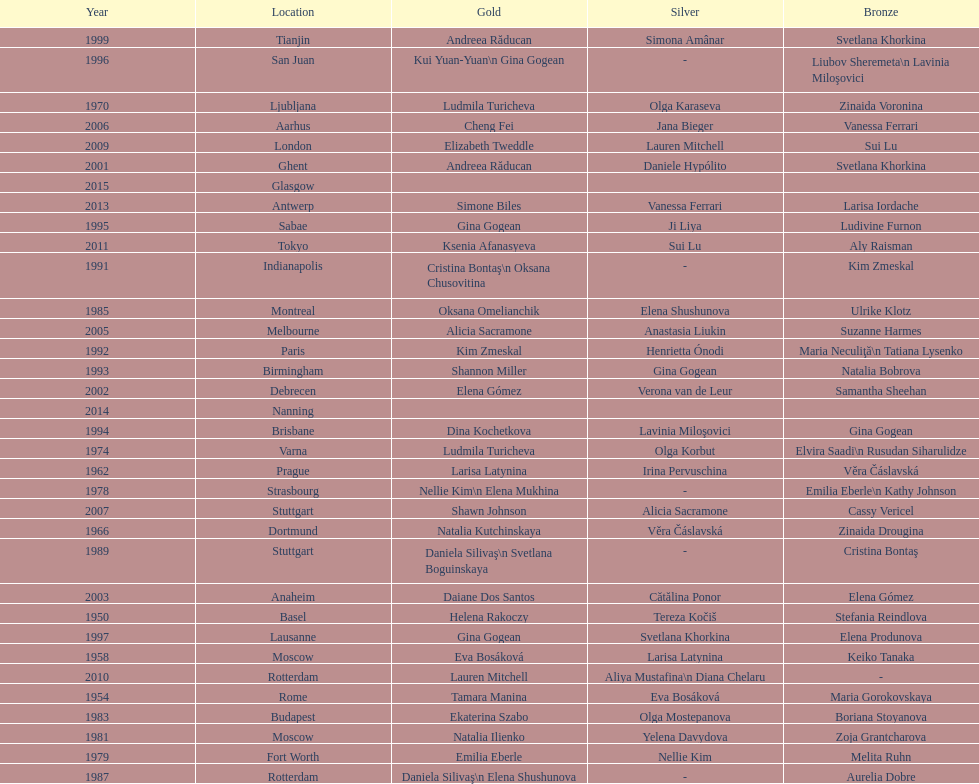How many times was the world artistic gymnastics championships held in the united states? 3. 